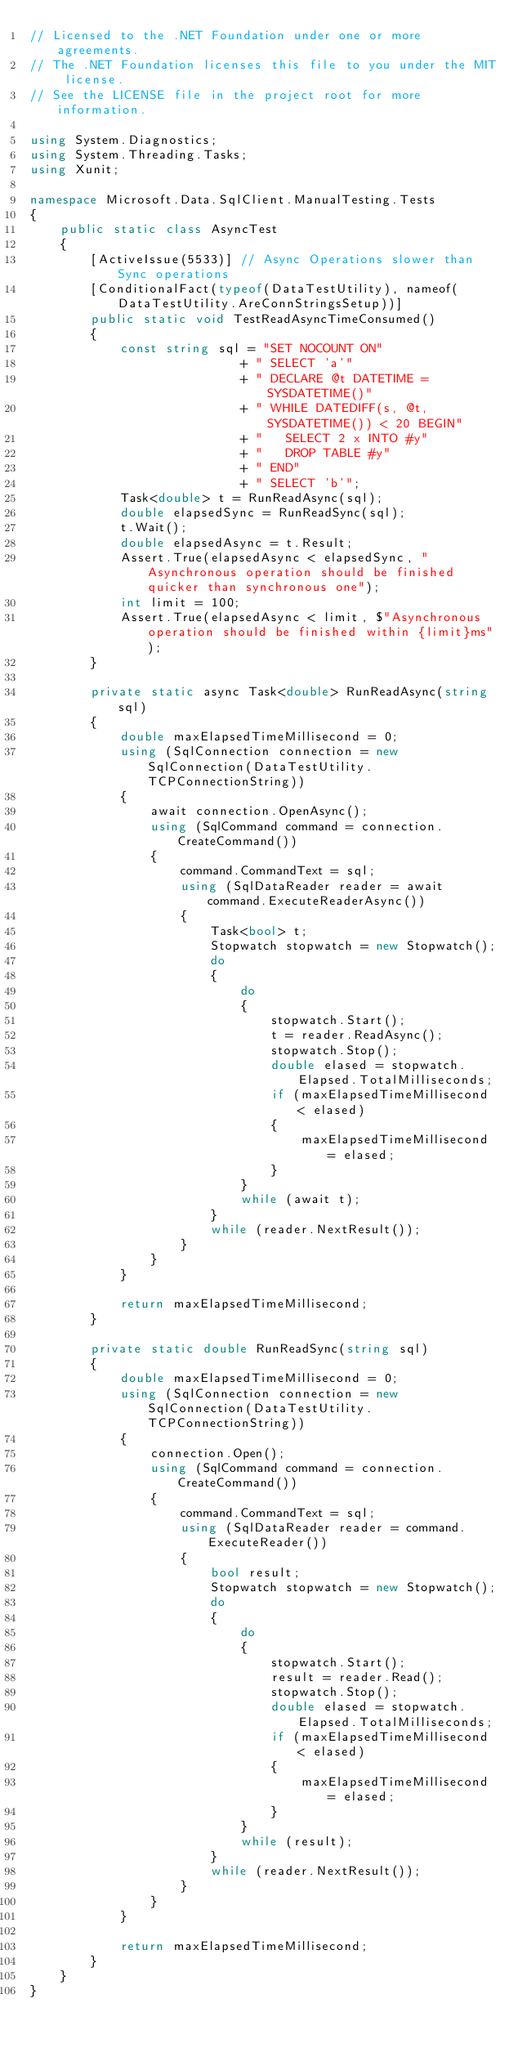<code> <loc_0><loc_0><loc_500><loc_500><_C#_>// Licensed to the .NET Foundation under one or more agreements.
// The .NET Foundation licenses this file to you under the MIT license.
// See the LICENSE file in the project root for more information.

using System.Diagnostics;
using System.Threading.Tasks;
using Xunit;

namespace Microsoft.Data.SqlClient.ManualTesting.Tests
{
    public static class AsyncTest
    {
        [ActiveIssue(5533)] // Async Operations slower than Sync operations
        [ConditionalFact(typeof(DataTestUtility), nameof(DataTestUtility.AreConnStringsSetup))]
        public static void TestReadAsyncTimeConsumed()
        {
            const string sql = "SET NOCOUNT ON"
                            + " SELECT 'a'"
                            + " DECLARE @t DATETIME = SYSDATETIME()"
                            + " WHILE DATEDIFF(s, @t, SYSDATETIME()) < 20 BEGIN"
                            + "   SELECT 2 x INTO #y"
                            + "   DROP TABLE #y"
                            + " END"
                            + " SELECT 'b'";
            Task<double> t = RunReadAsync(sql);
            double elapsedSync = RunReadSync(sql);
            t.Wait();
            double elapsedAsync = t.Result;
            Assert.True(elapsedAsync < elapsedSync, "Asynchronous operation should be finished quicker than synchronous one");
            int limit = 100;
            Assert.True(elapsedAsync < limit, $"Asynchronous operation should be finished within {limit}ms");
        }

        private static async Task<double> RunReadAsync(string sql)
        {
            double maxElapsedTimeMillisecond = 0;
            using (SqlConnection connection = new SqlConnection(DataTestUtility.TCPConnectionString))
            {
                await connection.OpenAsync();
                using (SqlCommand command = connection.CreateCommand())
                {
                    command.CommandText = sql;
                    using (SqlDataReader reader = await command.ExecuteReaderAsync())
                    {
                        Task<bool> t;
                        Stopwatch stopwatch = new Stopwatch();
                        do
                        {
                            do
                            {
                                stopwatch.Start();
                                t = reader.ReadAsync();
                                stopwatch.Stop();
                                double elased = stopwatch.Elapsed.TotalMilliseconds;
                                if (maxElapsedTimeMillisecond < elased)
                                {
                                    maxElapsedTimeMillisecond = elased;
                                }
                            }
                            while (await t);
                        }
                        while (reader.NextResult());
                    }
                }
            }

            return maxElapsedTimeMillisecond;
        }

        private static double RunReadSync(string sql)
        {
            double maxElapsedTimeMillisecond = 0;
            using (SqlConnection connection = new SqlConnection(DataTestUtility.TCPConnectionString))
            {
                connection.Open();
                using (SqlCommand command = connection.CreateCommand())
                {
                    command.CommandText = sql;
                    using (SqlDataReader reader = command.ExecuteReader())
                    {
                        bool result;
                        Stopwatch stopwatch = new Stopwatch();
                        do
                        {
                            do
                            {
                                stopwatch.Start();
                                result = reader.Read();
                                stopwatch.Stop();
                                double elased = stopwatch.Elapsed.TotalMilliseconds;
                                if (maxElapsedTimeMillisecond < elased)
                                {
                                    maxElapsedTimeMillisecond = elased;
                                }
                            }
                            while (result);
                        }
                        while (reader.NextResult());
                    }
                }
            }

            return maxElapsedTimeMillisecond;
        }
    }
}
</code> 